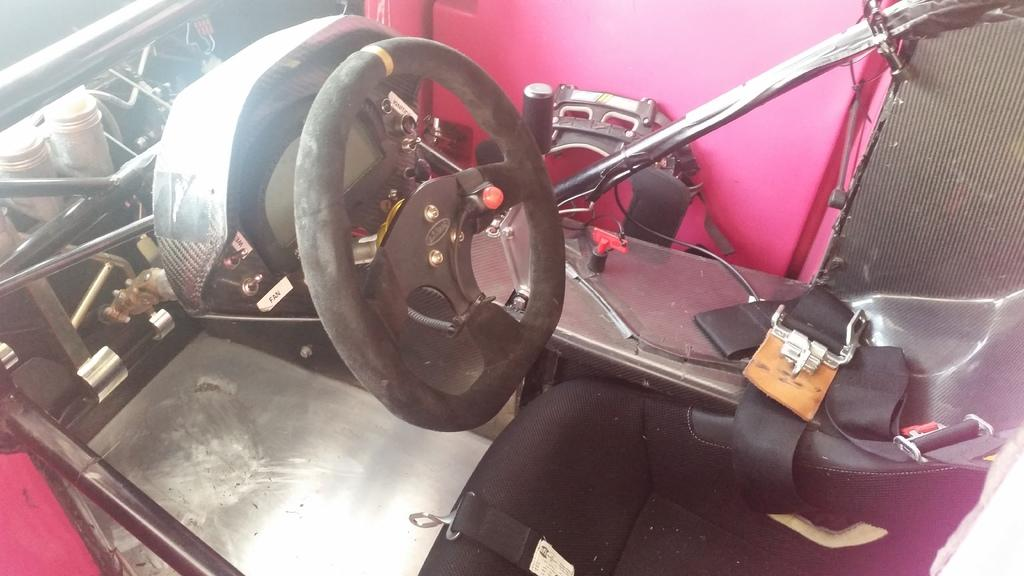What type of setting is depicted in the image? The image shows an inside view of a vehicle. What is the primary control mechanism in the vehicle? There is a steering wheel in the image. What material is used for the rods in the image? The rods in the image are made of metal. What type of legal advice is the lawyer providing in the image? There is no lawyer present in the image, as it shows an inside view of a vehicle. 